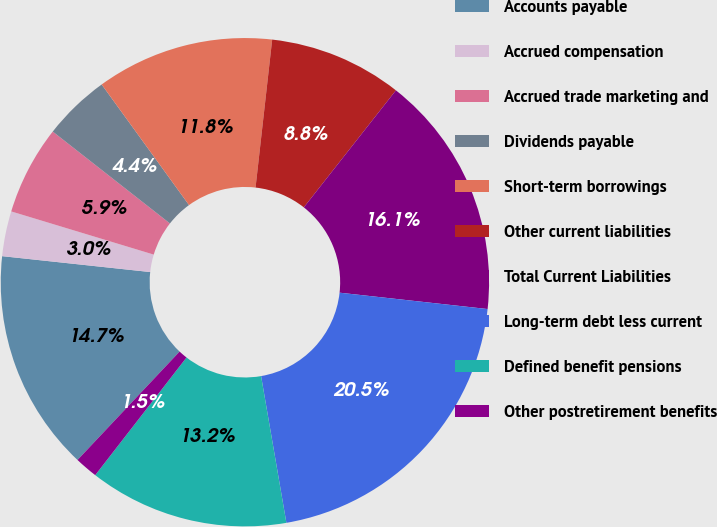<chart> <loc_0><loc_0><loc_500><loc_500><pie_chart><fcel>Accounts payable<fcel>Accrued compensation<fcel>Accrued trade marketing and<fcel>Dividends payable<fcel>Short-term borrowings<fcel>Other current liabilities<fcel>Total Current Liabilities<fcel>Long-term debt less current<fcel>Defined benefit pensions<fcel>Other postretirement benefits<nl><fcel>14.68%<fcel>2.98%<fcel>5.9%<fcel>4.44%<fcel>11.76%<fcel>8.83%<fcel>16.14%<fcel>20.53%<fcel>13.22%<fcel>1.52%<nl></chart> 